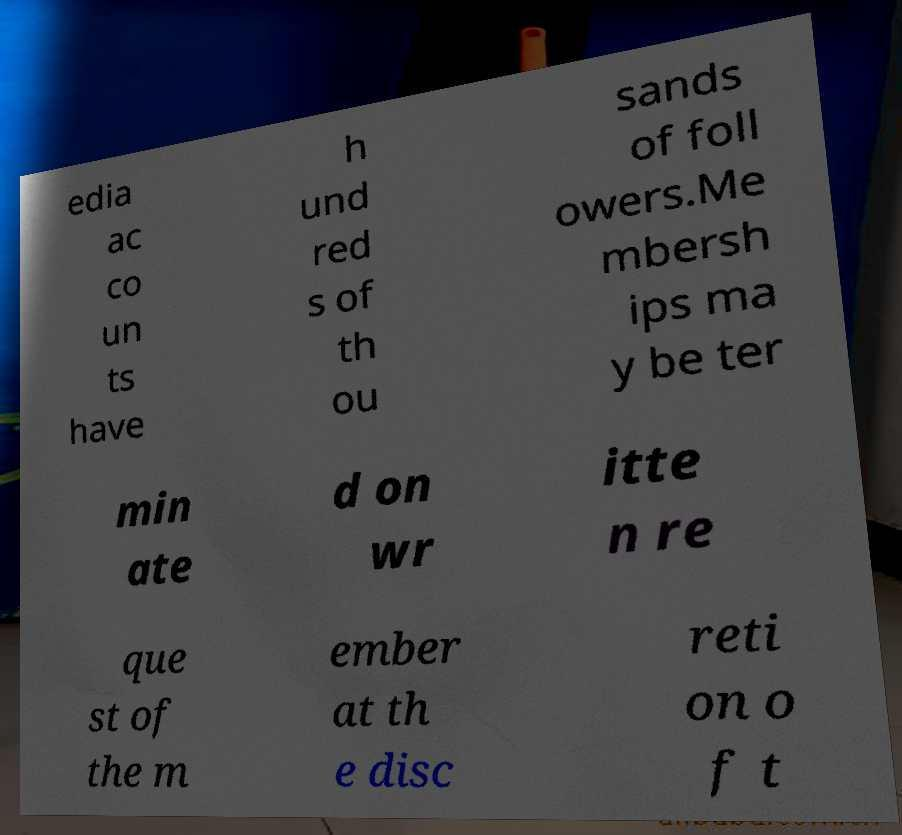Can you accurately transcribe the text from the provided image for me? edia ac co un ts have h und red s of th ou sands of foll owers.Me mbersh ips ma y be ter min ate d on wr itte n re que st of the m ember at th e disc reti on o f t 